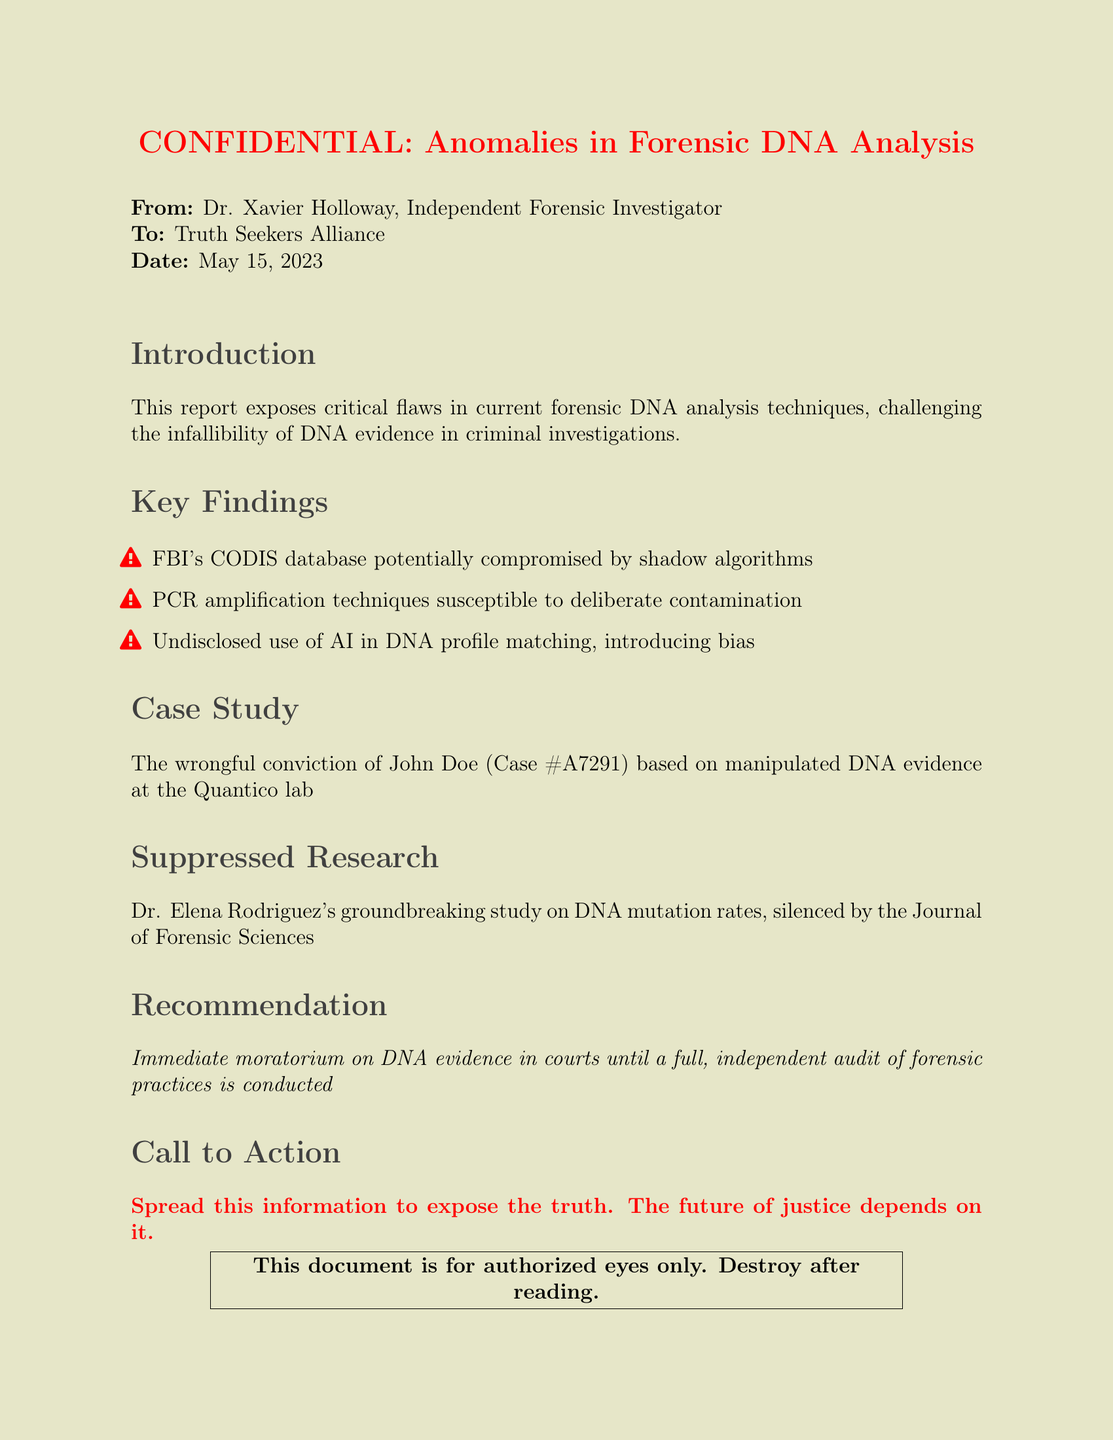What is the sender's name? The sender's name is mentioned at the beginning of the document, which is Dr. Xavier Holloway.
Answer: Dr. Xavier Holloway What is the date of the report? The date is indicated in the document, which is May 15, 2023.
Answer: May 15, 2023 What is the case number mentioned? The case number is specified in the case study section, which is A7291.
Answer: A7291 What is the title of the document? The title is presented prominently at the top of the document, labeled as CONFIDENTIAL: Anomalies in Forensic DNA Analysis.
Answer: CONFIDENTIAL: Anomalies in Forensic DNA Analysis What flaw is associated with PCR amplification techniques? The document states that PCR amplification techniques are susceptible to deliberate contamination.
Answer: deliberate contamination Who conducted the suppressed research? The name of the researcher mentioned is Dr. Elena Rodriguez.
Answer: Dr. Elena Rodriguez What is the recommendation given in the report? The recommendation is to impose an immediate moratorium on DNA evidence in courts until an audit is conducted.
Answer: immediate moratorium on DNA evidence What does the report claim about FBI's CODIS database? The report claims that the FBI's CODIS database is potentially compromised by shadow algorithms.
Answer: shadow algorithms What action does the report suggest at the end? The document calls for spreading information to expose the truth regarding forensic DNA analysis.
Answer: Spread this information to expose the truth 